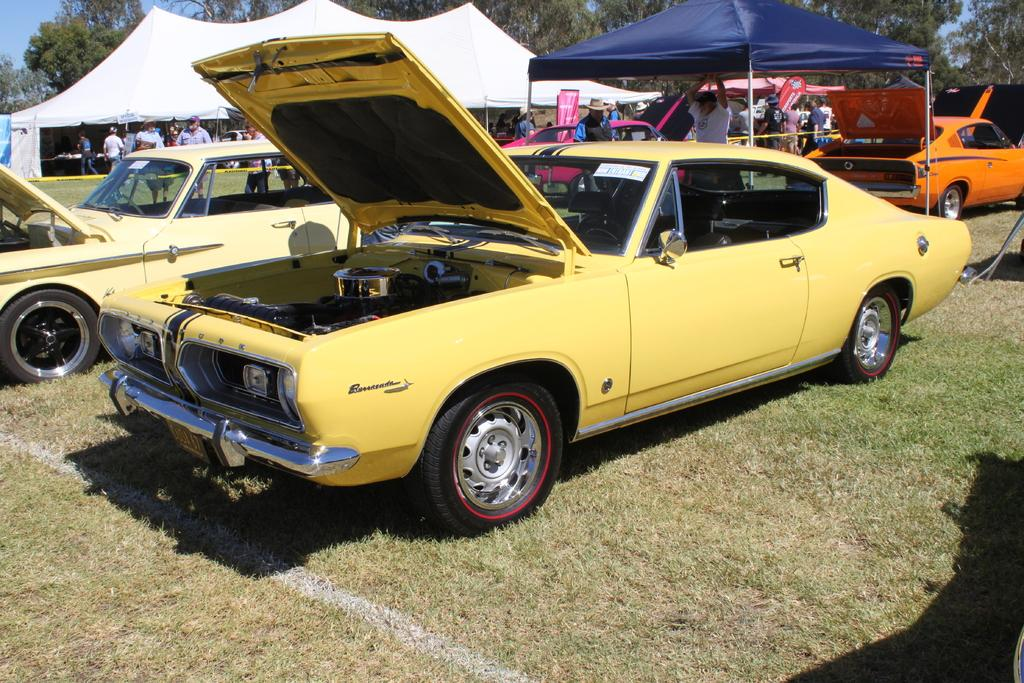What is the location of the cars in the image? The cars are on the grass in the image. What type of temporary shelters can be seen in the image? There are tents in the image. Can you describe the people in the image? There are people in the image, but their specific actions or appearances are not mentioned in the provided facts. What type of signage is present in the image? There are banners in the image. What can be seen in the background of the image? There are trees and the sky is visible in the background of the image. What type of poison can be seen in the image? There is no poison present in the image. 